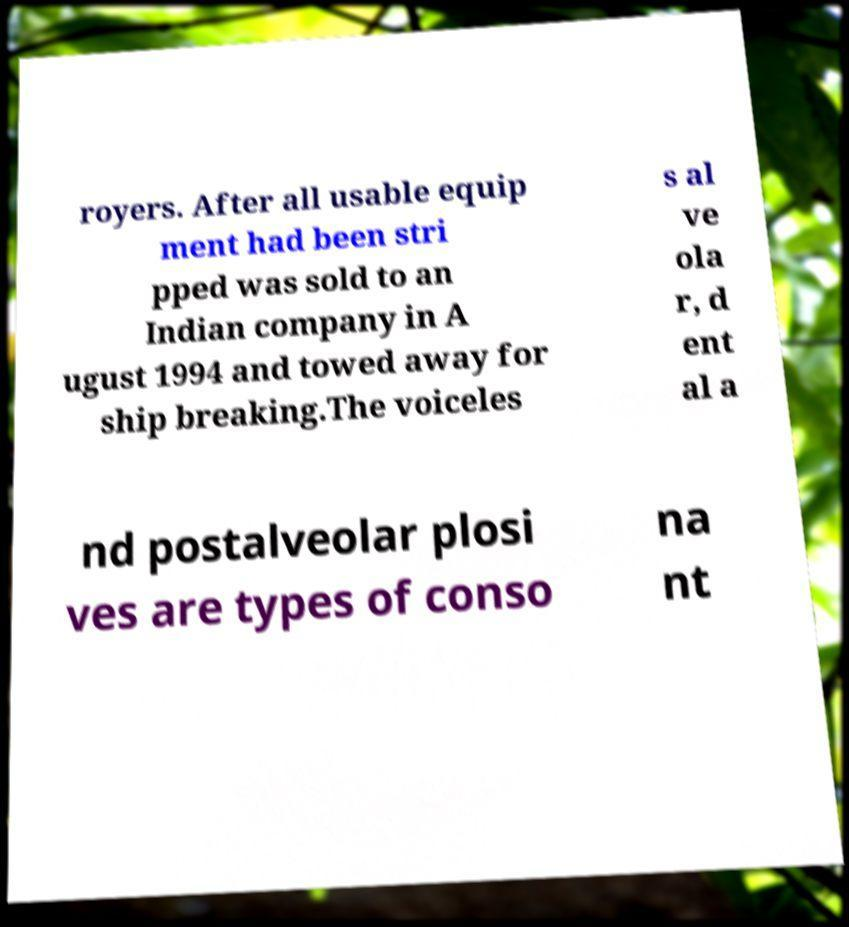Please read and relay the text visible in this image. What does it say? royers. After all usable equip ment had been stri pped was sold to an Indian company in A ugust 1994 and towed away for ship breaking.The voiceles s al ve ola r, d ent al a nd postalveolar plosi ves are types of conso na nt 